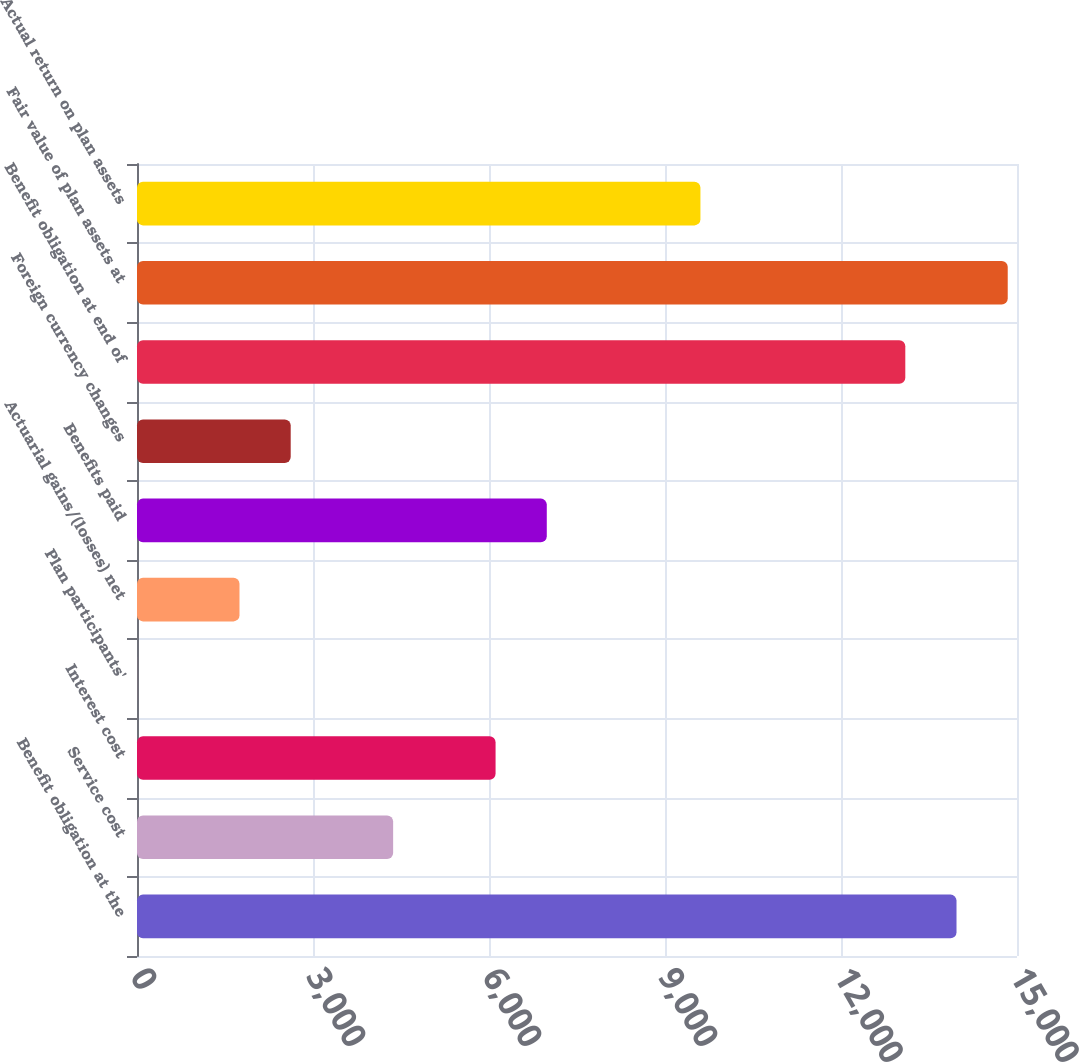Convert chart. <chart><loc_0><loc_0><loc_500><loc_500><bar_chart><fcel>Benefit obligation at the<fcel>Service cost<fcel>Interest cost<fcel>Plan participants'<fcel>Actuarial gains/(losses) net<fcel>Benefits paid<fcel>Foreign currency changes<fcel>Benefit obligation at end of<fcel>Fair value of plan assets at<fcel>Actual return on plan assets<nl><fcel>13969<fcel>4366<fcel>6112<fcel>1<fcel>1747<fcel>6985<fcel>2620<fcel>13096<fcel>14842<fcel>9604<nl></chart> 